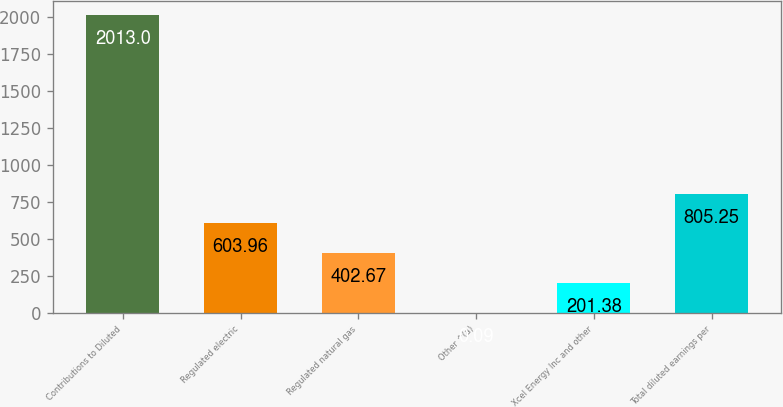Convert chart to OTSL. <chart><loc_0><loc_0><loc_500><loc_500><bar_chart><fcel>Contributions to Diluted<fcel>Regulated electric<fcel>Regulated natural gas<fcel>Other ^(a)<fcel>Xcel Energy Inc and other<fcel>Total diluted earnings per<nl><fcel>2013<fcel>603.96<fcel>402.67<fcel>0.09<fcel>201.38<fcel>805.25<nl></chart> 